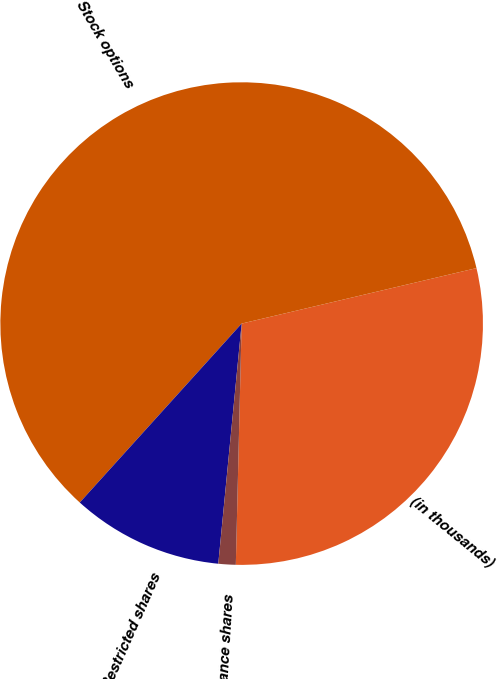<chart> <loc_0><loc_0><loc_500><loc_500><pie_chart><fcel>(in thousands)<fcel>Stock options<fcel>Restricted shares<fcel>Performance shares<nl><fcel>29.08%<fcel>59.61%<fcel>10.16%<fcel>1.16%<nl></chart> 